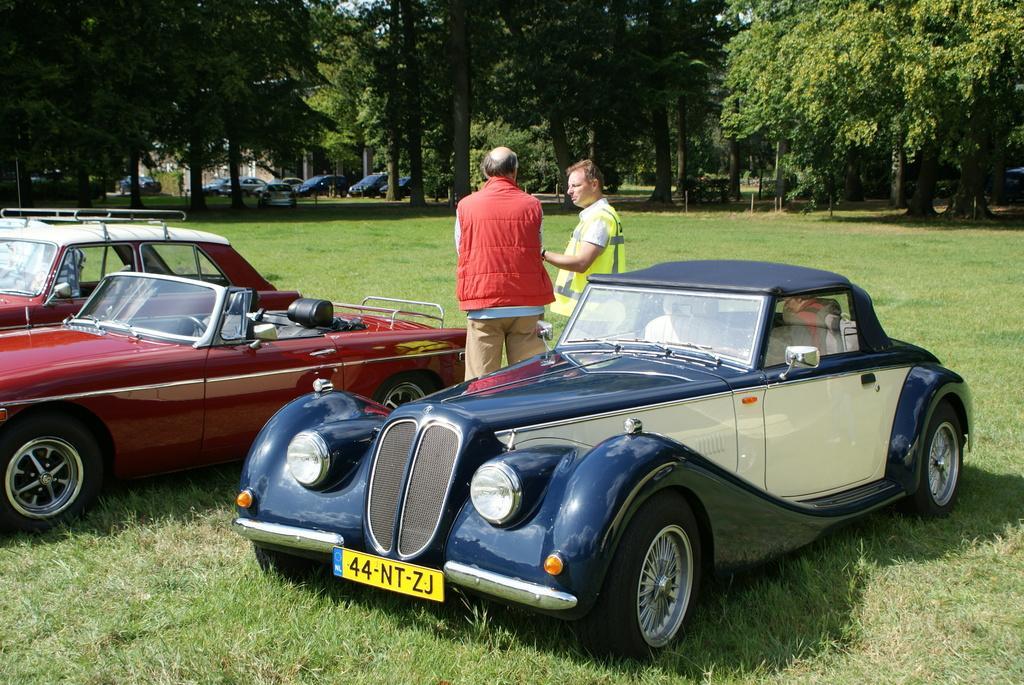How would you summarize this image in a sentence or two? In the image we can see there are many vehicles of different colors and shapes. Here we can see two men standing and wearing clothes. Here we can see grass, trees and a white sky. 